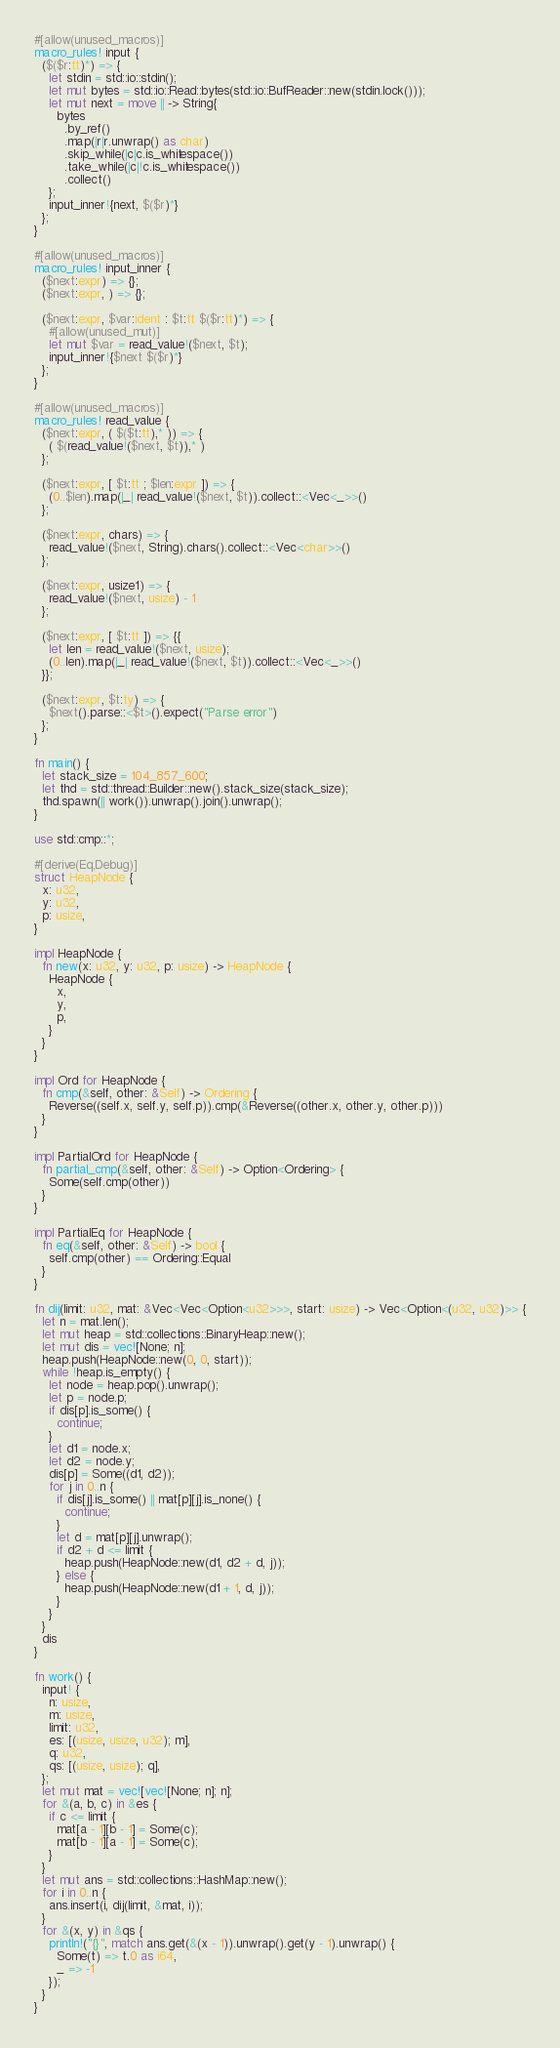<code> <loc_0><loc_0><loc_500><loc_500><_Rust_>#[allow(unused_macros)]
macro_rules! input {
  ($($r:tt)*) => {
    let stdin = std::io::stdin();
    let mut bytes = std::io::Read::bytes(std::io::BufReader::new(stdin.lock()));
    let mut next = move || -> String{
      bytes
        .by_ref()
        .map(|r|r.unwrap() as char)
        .skip_while(|c|c.is_whitespace())
        .take_while(|c|!c.is_whitespace())
        .collect()
    };
    input_inner!{next, $($r)*}
  };
}

#[allow(unused_macros)]
macro_rules! input_inner {
  ($next:expr) => {};
  ($next:expr, ) => {};

  ($next:expr, $var:ident : $t:tt $($r:tt)*) => {
    #[allow(unused_mut)]
    let mut $var = read_value!($next, $t);
    input_inner!{$next $($r)*}
  };
}

#[allow(unused_macros)]
macro_rules! read_value {
  ($next:expr, ( $($t:tt),* )) => {
    ( $(read_value!($next, $t)),* )
  };

  ($next:expr, [ $t:tt ; $len:expr ]) => {
    (0..$len).map(|_| read_value!($next, $t)).collect::<Vec<_>>()
  };

  ($next:expr, chars) => {
    read_value!($next, String).chars().collect::<Vec<char>>()
  };

  ($next:expr, usize1) => {
    read_value!($next, usize) - 1
  };

  ($next:expr, [ $t:tt ]) => {{
    let len = read_value!($next, usize);
    (0..len).map(|_| read_value!($next, $t)).collect::<Vec<_>>()
  }};

  ($next:expr, $t:ty) => {
    $next().parse::<$t>().expect("Parse error")
  };
}

fn main() {
  let stack_size = 104_857_600;
  let thd = std::thread::Builder::new().stack_size(stack_size);
  thd.spawn(|| work()).unwrap().join().unwrap();
}

use std::cmp::*;

#[derive(Eq,Debug)]
struct HeapNode {
  x: u32,
  y: u32,
  p: usize,
}

impl HeapNode {
  fn new(x: u32, y: u32, p: usize) -> HeapNode {
    HeapNode {
      x,
      y,
      p,
    }
  }
}

impl Ord for HeapNode {
  fn cmp(&self, other: &Self) -> Ordering {
    Reverse((self.x, self.y, self.p)).cmp(&Reverse((other.x, other.y, other.p)))
  }
}

impl PartialOrd for HeapNode {
  fn partial_cmp(&self, other: &Self) -> Option<Ordering> {
    Some(self.cmp(other))
  }
}

impl PartialEq for HeapNode {
  fn eq(&self, other: &Self) -> bool {
    self.cmp(other) == Ordering::Equal
  }
}

fn dij(limit: u32, mat: &Vec<Vec<Option<u32>>>, start: usize) -> Vec<Option<(u32, u32)>> {
  let n = mat.len();
  let mut heap = std::collections::BinaryHeap::new();
  let mut dis = vec![None; n];
  heap.push(HeapNode::new(0, 0, start));
  while !heap.is_empty() {
    let node = heap.pop().unwrap();
    let p = node.p;
    if dis[p].is_some() {
      continue;
    }
    let d1 = node.x;
    let d2 = node.y;
    dis[p] = Some((d1, d2));
    for j in 0..n {
      if dis[j].is_some() || mat[p][j].is_none() {
        continue;
      }
      let d = mat[p][j].unwrap();
      if d2 + d <= limit {
        heap.push(HeapNode::new(d1, d2 + d, j));
      } else {
        heap.push(HeapNode::new(d1 + 1, d, j));
      }
    }
  }
  dis
}

fn work() {
  input! {
    n: usize,
    m: usize,
    limit: u32,
    es: [(usize, usize, u32); m],
    q: u32,
    qs: [(usize, usize); q],
  };
  let mut mat = vec![vec![None; n]; n];
  for &(a, b, c) in &es {
    if c <= limit {
      mat[a - 1][b - 1] = Some(c);
      mat[b - 1][a - 1] = Some(c);
    }
  }
  let mut ans = std::collections::HashMap::new();
  for i in 0..n {
    ans.insert(i, dij(limit, &mat, i));
  }
  for &(x, y) in &qs {
    println!("{}", match ans.get(&(x - 1)).unwrap().get(y - 1).unwrap() {
      Some(t) => t.0 as i64,
      _ => -1
    });
  }
}
</code> 